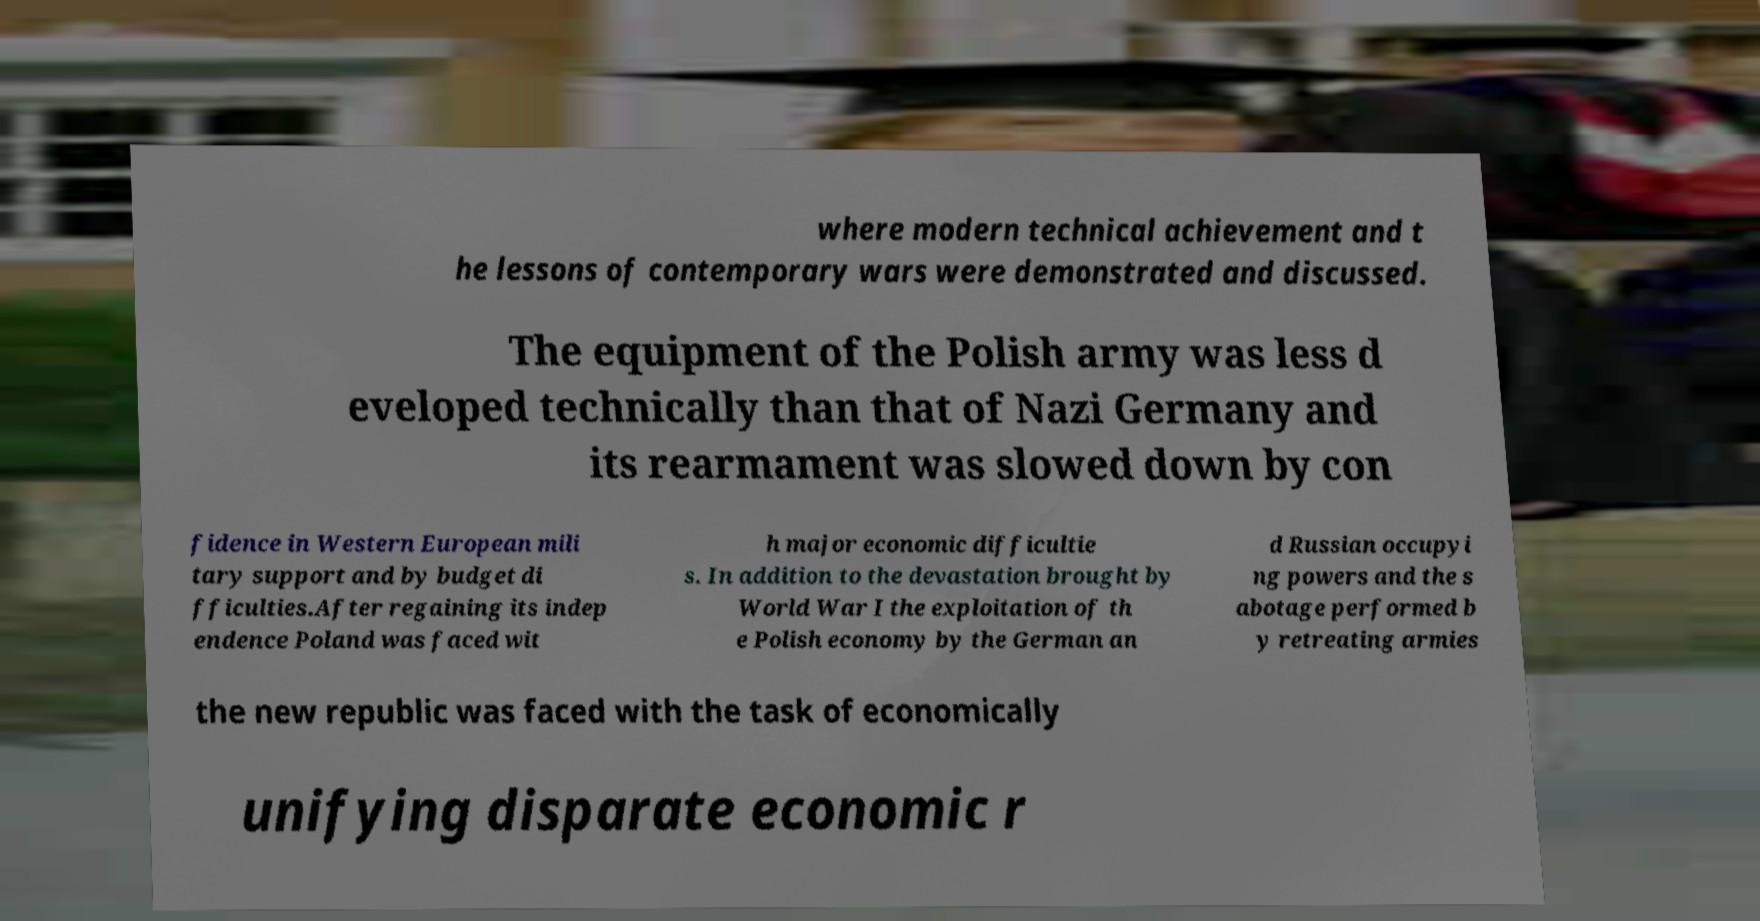Can you accurately transcribe the text from the provided image for me? where modern technical achievement and t he lessons of contemporary wars were demonstrated and discussed. The equipment of the Polish army was less d eveloped technically than that of Nazi Germany and its rearmament was slowed down by con fidence in Western European mili tary support and by budget di fficulties.After regaining its indep endence Poland was faced wit h major economic difficultie s. In addition to the devastation brought by World War I the exploitation of th e Polish economy by the German an d Russian occupyi ng powers and the s abotage performed b y retreating armies the new republic was faced with the task of economically unifying disparate economic r 